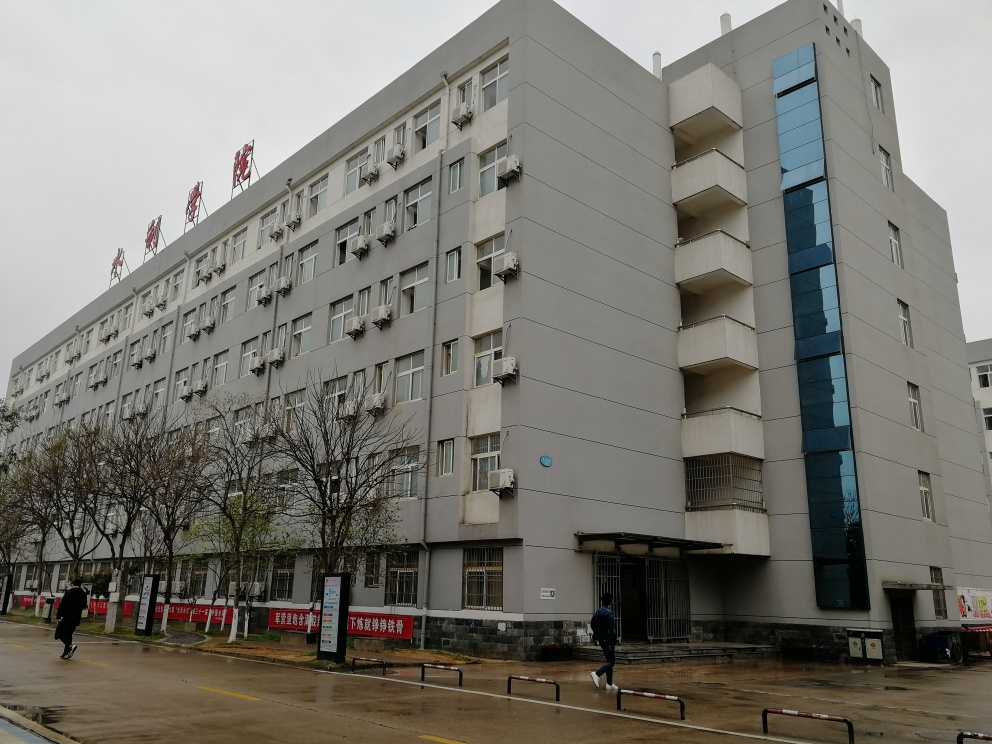Is the image pixelated? The image appears to be clear and not pixelated. Pixelation usually refers to an image being represented with large, visible individual pixels where the detail is not smooth, which is not observed here. The clarity of the image is likely sufficient for identifying features of the building, surrounding environment, and any other details. 